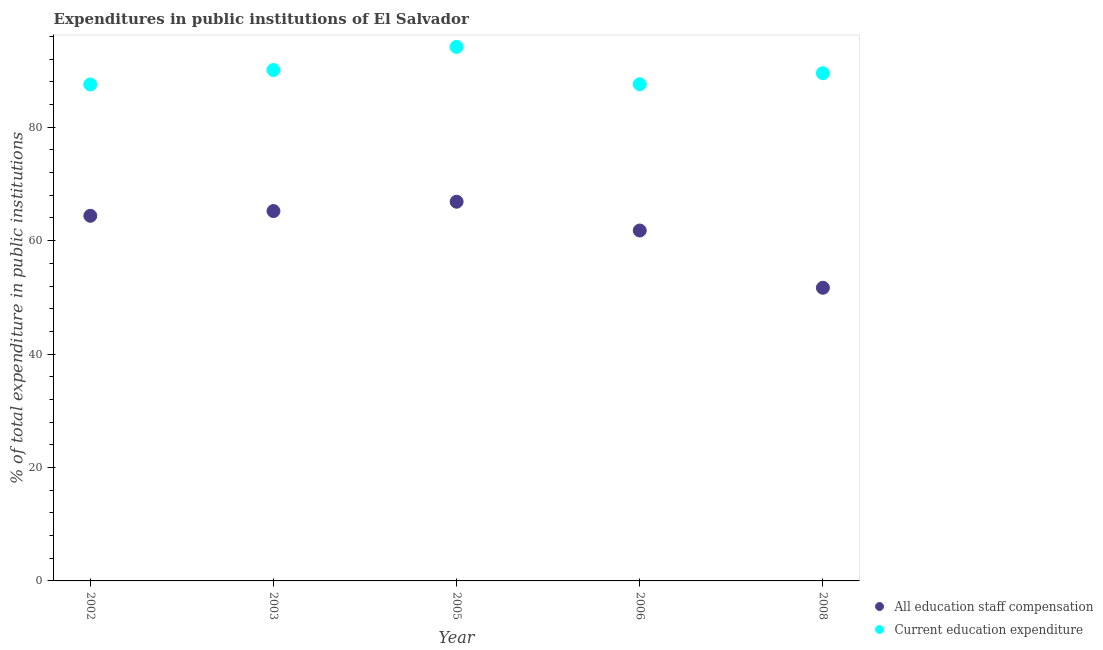What is the expenditure in staff compensation in 2002?
Provide a succinct answer. 64.38. Across all years, what is the maximum expenditure in education?
Your answer should be very brief. 94.16. Across all years, what is the minimum expenditure in education?
Keep it short and to the point. 87.54. In which year was the expenditure in staff compensation minimum?
Your response must be concise. 2008. What is the total expenditure in education in the graph?
Provide a succinct answer. 448.88. What is the difference between the expenditure in education in 2003 and that in 2005?
Provide a short and direct response. -4.07. What is the difference between the expenditure in staff compensation in 2006 and the expenditure in education in 2005?
Your answer should be very brief. -32.37. What is the average expenditure in staff compensation per year?
Ensure brevity in your answer.  61.99. In the year 2005, what is the difference between the expenditure in staff compensation and expenditure in education?
Make the answer very short. -27.3. What is the ratio of the expenditure in staff compensation in 2005 to that in 2006?
Make the answer very short. 1.08. Is the difference between the expenditure in education in 2003 and 2008 greater than the difference between the expenditure in staff compensation in 2003 and 2008?
Provide a succinct answer. No. What is the difference between the highest and the second highest expenditure in education?
Your answer should be very brief. 4.07. What is the difference between the highest and the lowest expenditure in education?
Your response must be concise. 6.62. Does the expenditure in staff compensation monotonically increase over the years?
Keep it short and to the point. No. Is the expenditure in education strictly less than the expenditure in staff compensation over the years?
Your answer should be very brief. No. How many years are there in the graph?
Offer a very short reply. 5. Does the graph contain any zero values?
Provide a succinct answer. No. Where does the legend appear in the graph?
Your response must be concise. Bottom right. What is the title of the graph?
Offer a terse response. Expenditures in public institutions of El Salvador. What is the label or title of the X-axis?
Keep it short and to the point. Year. What is the label or title of the Y-axis?
Offer a terse response. % of total expenditure in public institutions. What is the % of total expenditure in public institutions of All education staff compensation in 2002?
Provide a short and direct response. 64.38. What is the % of total expenditure in public institutions of Current education expenditure in 2002?
Offer a terse response. 87.54. What is the % of total expenditure in public institutions of All education staff compensation in 2003?
Provide a succinct answer. 65.22. What is the % of total expenditure in public institutions in Current education expenditure in 2003?
Your answer should be very brief. 90.09. What is the % of total expenditure in public institutions in All education staff compensation in 2005?
Ensure brevity in your answer.  66.86. What is the % of total expenditure in public institutions of Current education expenditure in 2005?
Offer a terse response. 94.16. What is the % of total expenditure in public institutions of All education staff compensation in 2006?
Provide a short and direct response. 61.79. What is the % of total expenditure in public institutions of Current education expenditure in 2006?
Make the answer very short. 87.58. What is the % of total expenditure in public institutions in All education staff compensation in 2008?
Ensure brevity in your answer.  51.69. What is the % of total expenditure in public institutions of Current education expenditure in 2008?
Give a very brief answer. 89.52. Across all years, what is the maximum % of total expenditure in public institutions of All education staff compensation?
Your response must be concise. 66.86. Across all years, what is the maximum % of total expenditure in public institutions of Current education expenditure?
Your answer should be compact. 94.16. Across all years, what is the minimum % of total expenditure in public institutions in All education staff compensation?
Keep it short and to the point. 51.69. Across all years, what is the minimum % of total expenditure in public institutions in Current education expenditure?
Provide a succinct answer. 87.54. What is the total % of total expenditure in public institutions in All education staff compensation in the graph?
Provide a succinct answer. 309.94. What is the total % of total expenditure in public institutions in Current education expenditure in the graph?
Offer a terse response. 448.88. What is the difference between the % of total expenditure in public institutions of All education staff compensation in 2002 and that in 2003?
Make the answer very short. -0.84. What is the difference between the % of total expenditure in public institutions in Current education expenditure in 2002 and that in 2003?
Offer a very short reply. -2.55. What is the difference between the % of total expenditure in public institutions of All education staff compensation in 2002 and that in 2005?
Offer a terse response. -2.48. What is the difference between the % of total expenditure in public institutions in Current education expenditure in 2002 and that in 2005?
Your answer should be very brief. -6.62. What is the difference between the % of total expenditure in public institutions in All education staff compensation in 2002 and that in 2006?
Your answer should be compact. 2.59. What is the difference between the % of total expenditure in public institutions in Current education expenditure in 2002 and that in 2006?
Make the answer very short. -0.04. What is the difference between the % of total expenditure in public institutions in All education staff compensation in 2002 and that in 2008?
Make the answer very short. 12.69. What is the difference between the % of total expenditure in public institutions in Current education expenditure in 2002 and that in 2008?
Provide a succinct answer. -1.98. What is the difference between the % of total expenditure in public institutions in All education staff compensation in 2003 and that in 2005?
Keep it short and to the point. -1.65. What is the difference between the % of total expenditure in public institutions in Current education expenditure in 2003 and that in 2005?
Make the answer very short. -4.07. What is the difference between the % of total expenditure in public institutions of All education staff compensation in 2003 and that in 2006?
Make the answer very short. 3.43. What is the difference between the % of total expenditure in public institutions of Current education expenditure in 2003 and that in 2006?
Your answer should be very brief. 2.51. What is the difference between the % of total expenditure in public institutions of All education staff compensation in 2003 and that in 2008?
Make the answer very short. 13.53. What is the difference between the % of total expenditure in public institutions in Current education expenditure in 2003 and that in 2008?
Provide a short and direct response. 0.57. What is the difference between the % of total expenditure in public institutions of All education staff compensation in 2005 and that in 2006?
Make the answer very short. 5.08. What is the difference between the % of total expenditure in public institutions in Current education expenditure in 2005 and that in 2006?
Provide a short and direct response. 6.58. What is the difference between the % of total expenditure in public institutions of All education staff compensation in 2005 and that in 2008?
Provide a short and direct response. 15.17. What is the difference between the % of total expenditure in public institutions of Current education expenditure in 2005 and that in 2008?
Ensure brevity in your answer.  4.64. What is the difference between the % of total expenditure in public institutions in All education staff compensation in 2006 and that in 2008?
Provide a succinct answer. 10.09. What is the difference between the % of total expenditure in public institutions in Current education expenditure in 2006 and that in 2008?
Provide a short and direct response. -1.94. What is the difference between the % of total expenditure in public institutions of All education staff compensation in 2002 and the % of total expenditure in public institutions of Current education expenditure in 2003?
Your response must be concise. -25.71. What is the difference between the % of total expenditure in public institutions of All education staff compensation in 2002 and the % of total expenditure in public institutions of Current education expenditure in 2005?
Provide a short and direct response. -29.78. What is the difference between the % of total expenditure in public institutions of All education staff compensation in 2002 and the % of total expenditure in public institutions of Current education expenditure in 2006?
Your answer should be very brief. -23.2. What is the difference between the % of total expenditure in public institutions of All education staff compensation in 2002 and the % of total expenditure in public institutions of Current education expenditure in 2008?
Your response must be concise. -25.14. What is the difference between the % of total expenditure in public institutions in All education staff compensation in 2003 and the % of total expenditure in public institutions in Current education expenditure in 2005?
Offer a very short reply. -28.94. What is the difference between the % of total expenditure in public institutions of All education staff compensation in 2003 and the % of total expenditure in public institutions of Current education expenditure in 2006?
Offer a terse response. -22.36. What is the difference between the % of total expenditure in public institutions in All education staff compensation in 2003 and the % of total expenditure in public institutions in Current education expenditure in 2008?
Your answer should be very brief. -24.3. What is the difference between the % of total expenditure in public institutions in All education staff compensation in 2005 and the % of total expenditure in public institutions in Current education expenditure in 2006?
Make the answer very short. -20.71. What is the difference between the % of total expenditure in public institutions of All education staff compensation in 2005 and the % of total expenditure in public institutions of Current education expenditure in 2008?
Your response must be concise. -22.65. What is the difference between the % of total expenditure in public institutions of All education staff compensation in 2006 and the % of total expenditure in public institutions of Current education expenditure in 2008?
Your answer should be compact. -27.73. What is the average % of total expenditure in public institutions of All education staff compensation per year?
Make the answer very short. 61.99. What is the average % of total expenditure in public institutions of Current education expenditure per year?
Your response must be concise. 89.78. In the year 2002, what is the difference between the % of total expenditure in public institutions of All education staff compensation and % of total expenditure in public institutions of Current education expenditure?
Offer a terse response. -23.16. In the year 2003, what is the difference between the % of total expenditure in public institutions in All education staff compensation and % of total expenditure in public institutions in Current education expenditure?
Give a very brief answer. -24.87. In the year 2005, what is the difference between the % of total expenditure in public institutions of All education staff compensation and % of total expenditure in public institutions of Current education expenditure?
Provide a short and direct response. -27.3. In the year 2006, what is the difference between the % of total expenditure in public institutions of All education staff compensation and % of total expenditure in public institutions of Current education expenditure?
Offer a very short reply. -25.79. In the year 2008, what is the difference between the % of total expenditure in public institutions in All education staff compensation and % of total expenditure in public institutions in Current education expenditure?
Give a very brief answer. -37.83. What is the ratio of the % of total expenditure in public institutions in All education staff compensation in 2002 to that in 2003?
Offer a very short reply. 0.99. What is the ratio of the % of total expenditure in public institutions of Current education expenditure in 2002 to that in 2003?
Keep it short and to the point. 0.97. What is the ratio of the % of total expenditure in public institutions in All education staff compensation in 2002 to that in 2005?
Your answer should be compact. 0.96. What is the ratio of the % of total expenditure in public institutions of Current education expenditure in 2002 to that in 2005?
Provide a short and direct response. 0.93. What is the ratio of the % of total expenditure in public institutions in All education staff compensation in 2002 to that in 2006?
Offer a terse response. 1.04. What is the ratio of the % of total expenditure in public institutions in All education staff compensation in 2002 to that in 2008?
Make the answer very short. 1.25. What is the ratio of the % of total expenditure in public institutions in Current education expenditure in 2002 to that in 2008?
Offer a very short reply. 0.98. What is the ratio of the % of total expenditure in public institutions in All education staff compensation in 2003 to that in 2005?
Give a very brief answer. 0.98. What is the ratio of the % of total expenditure in public institutions in Current education expenditure in 2003 to that in 2005?
Your answer should be very brief. 0.96. What is the ratio of the % of total expenditure in public institutions of All education staff compensation in 2003 to that in 2006?
Offer a very short reply. 1.06. What is the ratio of the % of total expenditure in public institutions in Current education expenditure in 2003 to that in 2006?
Offer a very short reply. 1.03. What is the ratio of the % of total expenditure in public institutions of All education staff compensation in 2003 to that in 2008?
Provide a short and direct response. 1.26. What is the ratio of the % of total expenditure in public institutions of Current education expenditure in 2003 to that in 2008?
Make the answer very short. 1.01. What is the ratio of the % of total expenditure in public institutions in All education staff compensation in 2005 to that in 2006?
Your response must be concise. 1.08. What is the ratio of the % of total expenditure in public institutions in Current education expenditure in 2005 to that in 2006?
Provide a succinct answer. 1.08. What is the ratio of the % of total expenditure in public institutions in All education staff compensation in 2005 to that in 2008?
Offer a terse response. 1.29. What is the ratio of the % of total expenditure in public institutions in Current education expenditure in 2005 to that in 2008?
Keep it short and to the point. 1.05. What is the ratio of the % of total expenditure in public institutions of All education staff compensation in 2006 to that in 2008?
Your answer should be very brief. 1.2. What is the ratio of the % of total expenditure in public institutions in Current education expenditure in 2006 to that in 2008?
Provide a short and direct response. 0.98. What is the difference between the highest and the second highest % of total expenditure in public institutions in All education staff compensation?
Keep it short and to the point. 1.65. What is the difference between the highest and the second highest % of total expenditure in public institutions of Current education expenditure?
Offer a very short reply. 4.07. What is the difference between the highest and the lowest % of total expenditure in public institutions in All education staff compensation?
Your answer should be very brief. 15.17. What is the difference between the highest and the lowest % of total expenditure in public institutions of Current education expenditure?
Your response must be concise. 6.62. 